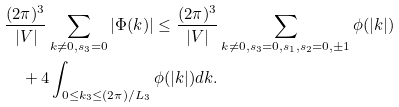<formula> <loc_0><loc_0><loc_500><loc_500>& \frac { ( 2 \pi ) ^ { 3 } } { | V | } \sum _ { k \not = 0 , s _ { 3 } = 0 } | \Phi ( k ) | \leq \frac { ( 2 \pi ) ^ { 3 } } { | V | } \sum _ { k \not = 0 , s _ { 3 } = 0 , s _ { 1 } , s _ { 2 } = 0 , \pm 1 } \phi ( | k | ) \\ & \quad + 4 \int _ { 0 \leq k _ { 3 } \leq ( 2 \pi ) / L _ { 3 } } \phi ( | k | ) d k .</formula> 